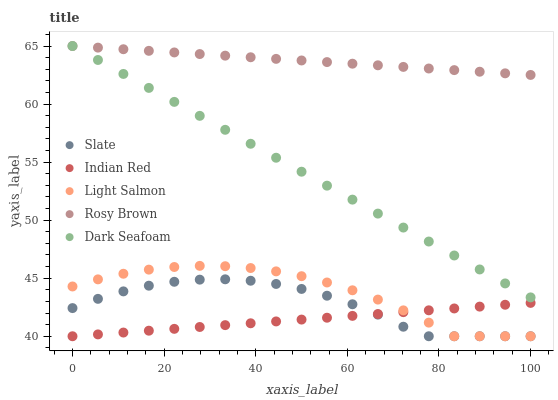Does Indian Red have the minimum area under the curve?
Answer yes or no. Yes. Does Rosy Brown have the maximum area under the curve?
Answer yes or no. Yes. Does Slate have the minimum area under the curve?
Answer yes or no. No. Does Slate have the maximum area under the curve?
Answer yes or no. No. Is Dark Seafoam the smoothest?
Answer yes or no. Yes. Is Light Salmon the roughest?
Answer yes or no. Yes. Is Slate the smoothest?
Answer yes or no. No. Is Slate the roughest?
Answer yes or no. No. Does Slate have the lowest value?
Answer yes or no. Yes. Does Rosy Brown have the lowest value?
Answer yes or no. No. Does Rosy Brown have the highest value?
Answer yes or no. Yes. Does Slate have the highest value?
Answer yes or no. No. Is Indian Red less than Rosy Brown?
Answer yes or no. Yes. Is Rosy Brown greater than Indian Red?
Answer yes or no. Yes. Does Indian Red intersect Slate?
Answer yes or no. Yes. Is Indian Red less than Slate?
Answer yes or no. No. Is Indian Red greater than Slate?
Answer yes or no. No. Does Indian Red intersect Rosy Brown?
Answer yes or no. No. 